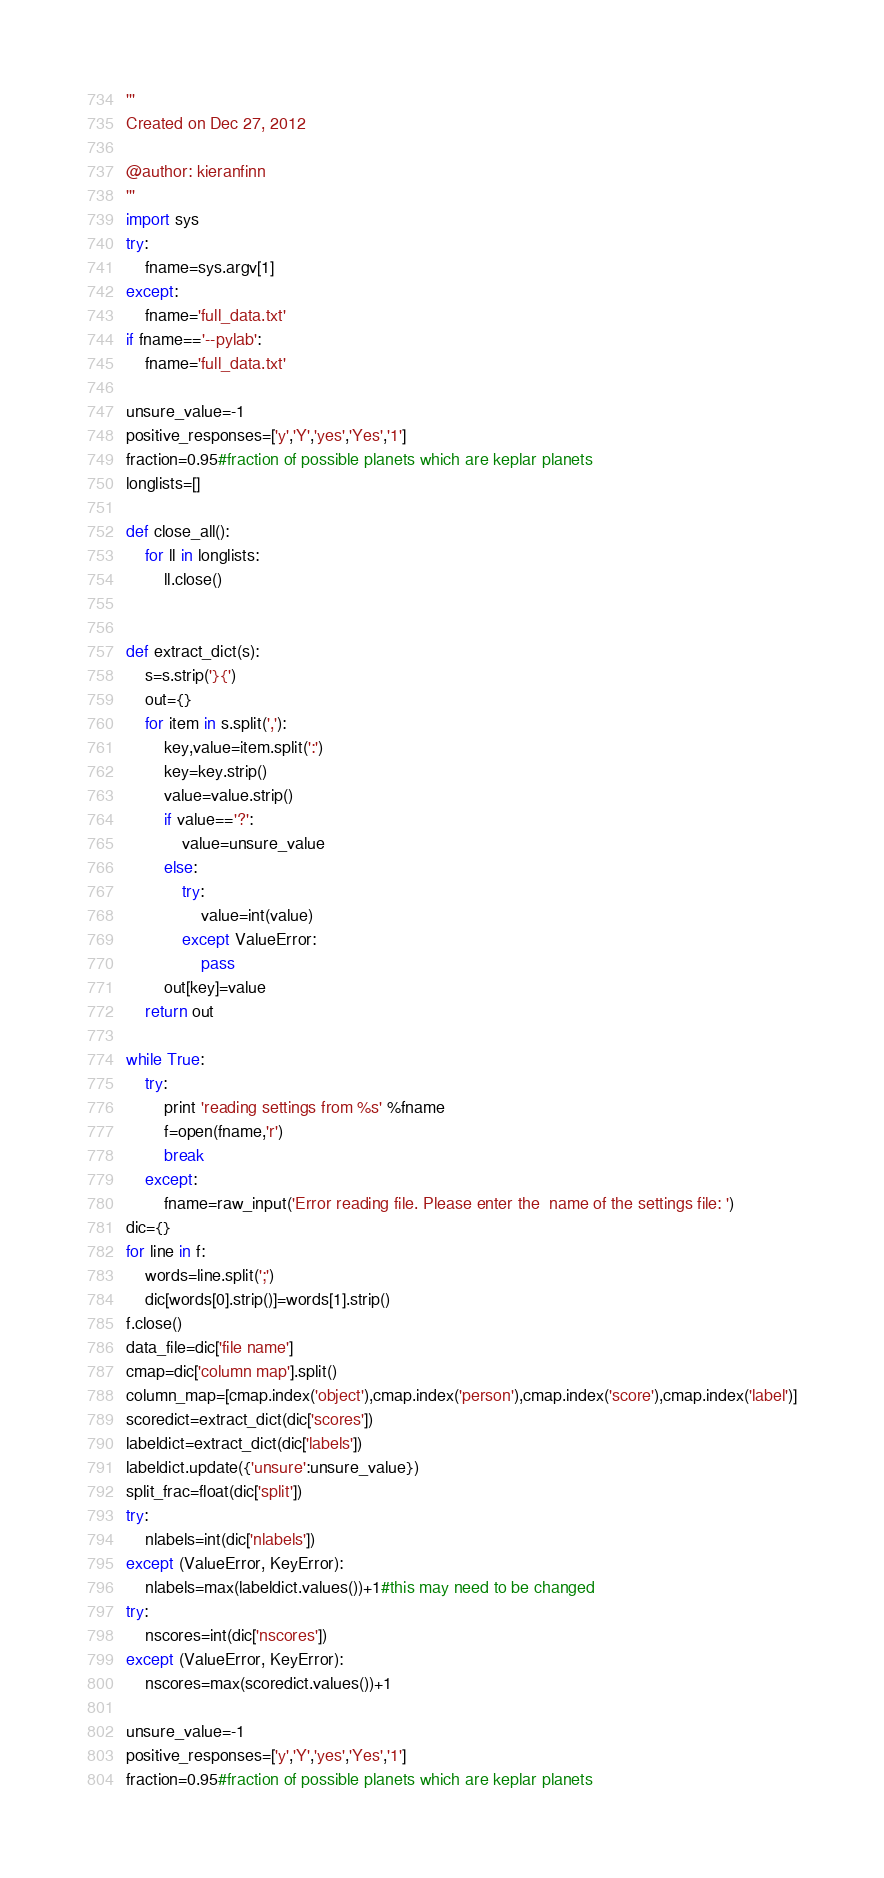Convert code to text. <code><loc_0><loc_0><loc_500><loc_500><_Python_>'''
Created on Dec 27, 2012

@author: kieranfinn
'''
import sys
try:
    fname=sys.argv[1]
except:
    fname='full_data.txt'
if fname=='--pylab':
    fname='full_data.txt'
     
unsure_value=-1
positive_responses=['y','Y','yes','Yes','1']
fraction=0.95#fraction of possible planets which are keplar planets
longlists=[]

def close_all():
    for ll in longlists:
        ll.close()
        

def extract_dict(s):
    s=s.strip('}{')
    out={}
    for item in s.split(','):
        key,value=item.split(':')
        key=key.strip()
        value=value.strip()
        if value=='?':
            value=unsure_value
        else:
            try:
                value=int(value)
            except ValueError:
                pass
        out[key]=value
    return out

while True:
    try:
        print 'reading settings from %s' %fname
        f=open(fname,'r')
        break
    except:
        fname=raw_input('Error reading file. Please enter the  name of the settings file: ')
dic={}
for line in f:
    words=line.split(';')
    dic[words[0].strip()]=words[1].strip()
f.close()
data_file=dic['file name']
cmap=dic['column map'].split()
column_map=[cmap.index('object'),cmap.index('person'),cmap.index('score'),cmap.index('label')]
scoredict=extract_dict(dic['scores'])
labeldict=extract_dict(dic['labels'])
labeldict.update({'unsure':unsure_value})
split_frac=float(dic['split'])
try:
    nlabels=int(dic['nlabels'])
except (ValueError, KeyError):
    nlabels=max(labeldict.values())+1#this may need to be changed
try:
    nscores=int(dic['nscores'])
except (ValueError, KeyError):
    nscores=max(scoredict.values())+1
            
unsure_value=-1
positive_responses=['y','Y','yes','Yes','1']
fraction=0.95#fraction of possible planets which are keplar planets</code> 